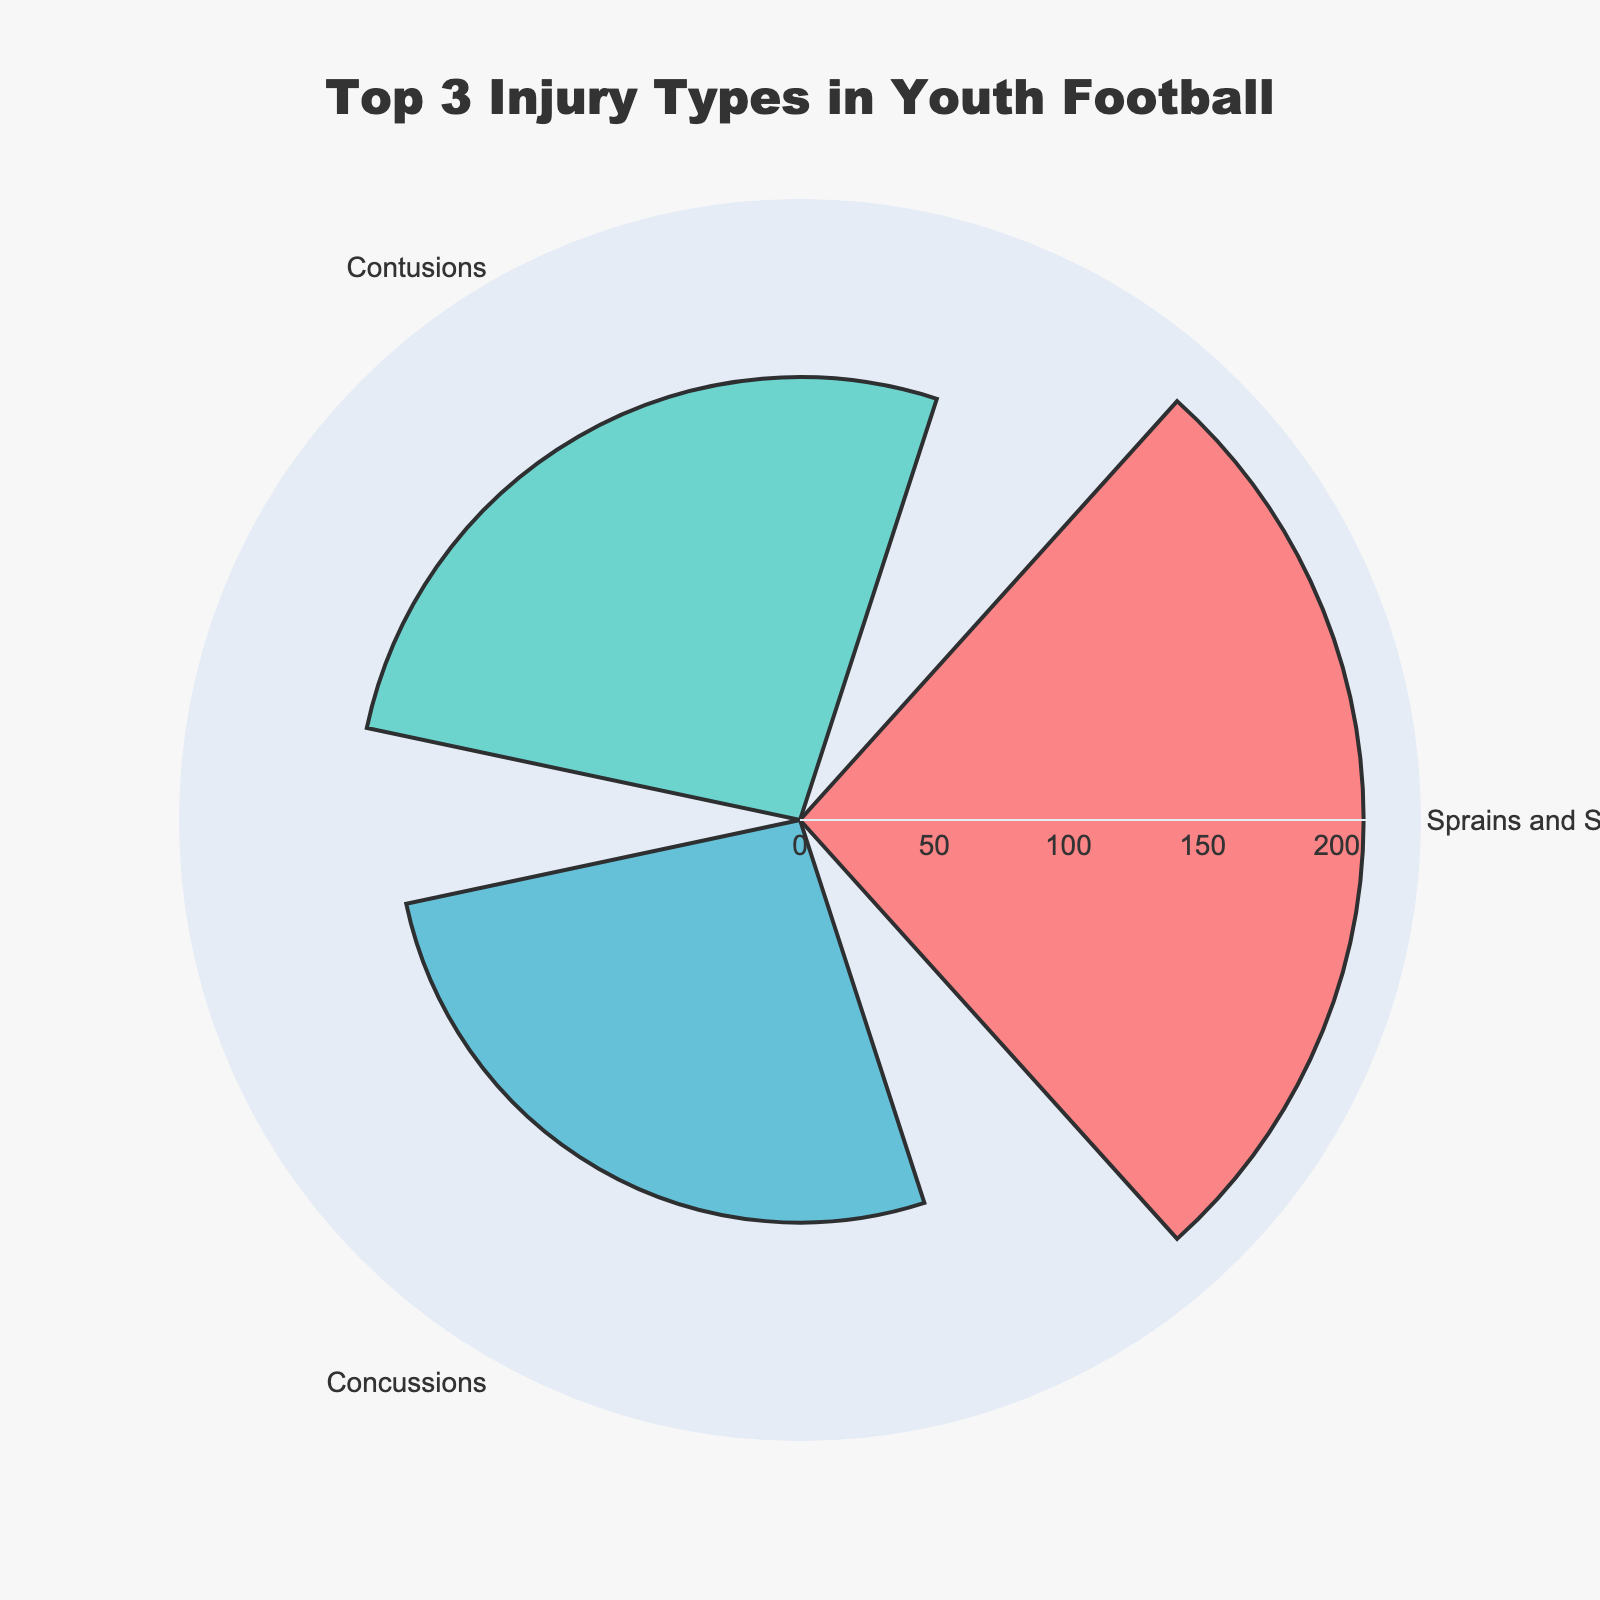What's the title of the chart? The title of the chart is displayed at the top center and reads "Top 3 Injury Types in Youth Football".
Answer: Top 3 Injury Types in Youth Football How many types of injuries are displayed? The chart shows the names of the injury types in the polar region. There are three types: Concussions, Sprains and Strains, and Contusions.
Answer: Three Which type of injury has the highest number of incidents? The radial bars indicate the number of incidents. The longest bar corresponds to Sprains and Strains.
Answer: Sprains and Strains Compare the number of incidents of Concussions and Contusions. Which one has more? By comparing the length of the bars, Contusions has a slightly longer bar, indicating more incidents than Concussions.
Answer: Contusions What is the range of the radial axis? The radial axis extends from 0 to a value slightly above the maximum number of incidents shown. Looking at the grid and considering the highest incident count (210 for Sprains and Strains), the range is from 0 to approximately 231.
Answer: 0 to approximately 231 How many more incidents of Sprains and Strains are there compared to Fractures? The number of incidents for Sprains and Strains is 210. For Fractures, it's 95. The difference is calculated by subtracting 95 from 210.
Answer: 115 more incidents If the total number of incidents for these three injury types is calculated, what is it? Sum up the number of incidents for the top three injury types: 150 (Concussions) + 210 (Sprains and Strains) + 165 (Contusions). The total is 525.
Answer: 525 Which two injury types have the closest number of incidents? By comparing the radial lengths, Concussions (150) and Contusions (165) have incident counts that are closer to each other than any other pair.
Answer: Concussions and Contusions What color represents Concussions in the chart? The colors in the radial bars can be identified visually. Concussions are represented by the color red.
Answer: Red How many more incidents of Contusions are there compared to Concussions? The incidences for Contusions and Concussions are 165 and 150 respectively. So, the difference is 165 - 150.
Answer: 15 more incidents 